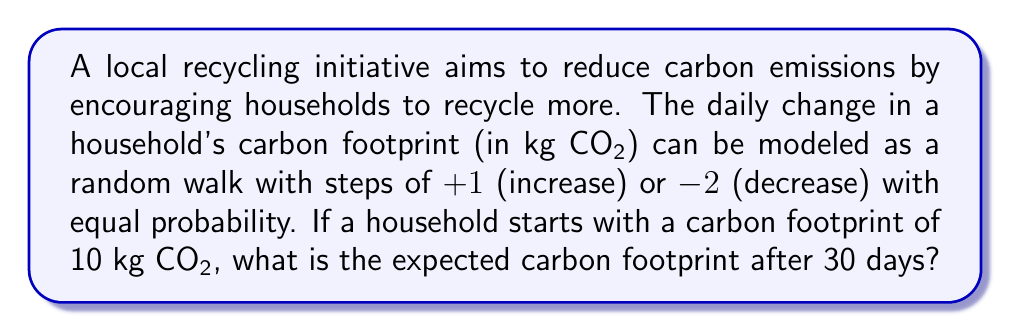Can you solve this math problem? Let's approach this step-by-step:

1) In a random walk, the expected position after n steps is given by:
   $$E[X_n] = X_0 + n \cdot E[\Delta X]$$
   where $X_0$ is the initial position and $E[\Delta X]$ is the expected change per step.

2) In this case:
   $X_0 = 10$ kg CO₂ (initial carbon footprint)
   $n = 30$ days

3) To calculate $E[\Delta X]$:
   - With probability 0.5, the step is +1
   - With probability 0.5, the step is -2
   
   $$E[\Delta X] = 0.5 \cdot (+1) + 0.5 \cdot (-2) = 0.5 - 1 = -0.5$$ kg CO₂

4) Now we can calculate the expected carbon footprint after 30 days:
   $$E[X_{30}] = 10 + 30 \cdot (-0.5) = 10 - 15 = -5$$ kg CO₂

5) However, carbon footprint cannot be negative. In reality, this means the household is likely offsetting more carbon than it produces. For practical purposes, we can consider this as reaching a net-zero carbon footprint.

Therefore, the expected carbon footprint after 30 days is 0 kg CO₂.
Answer: 0 kg CO₂ 